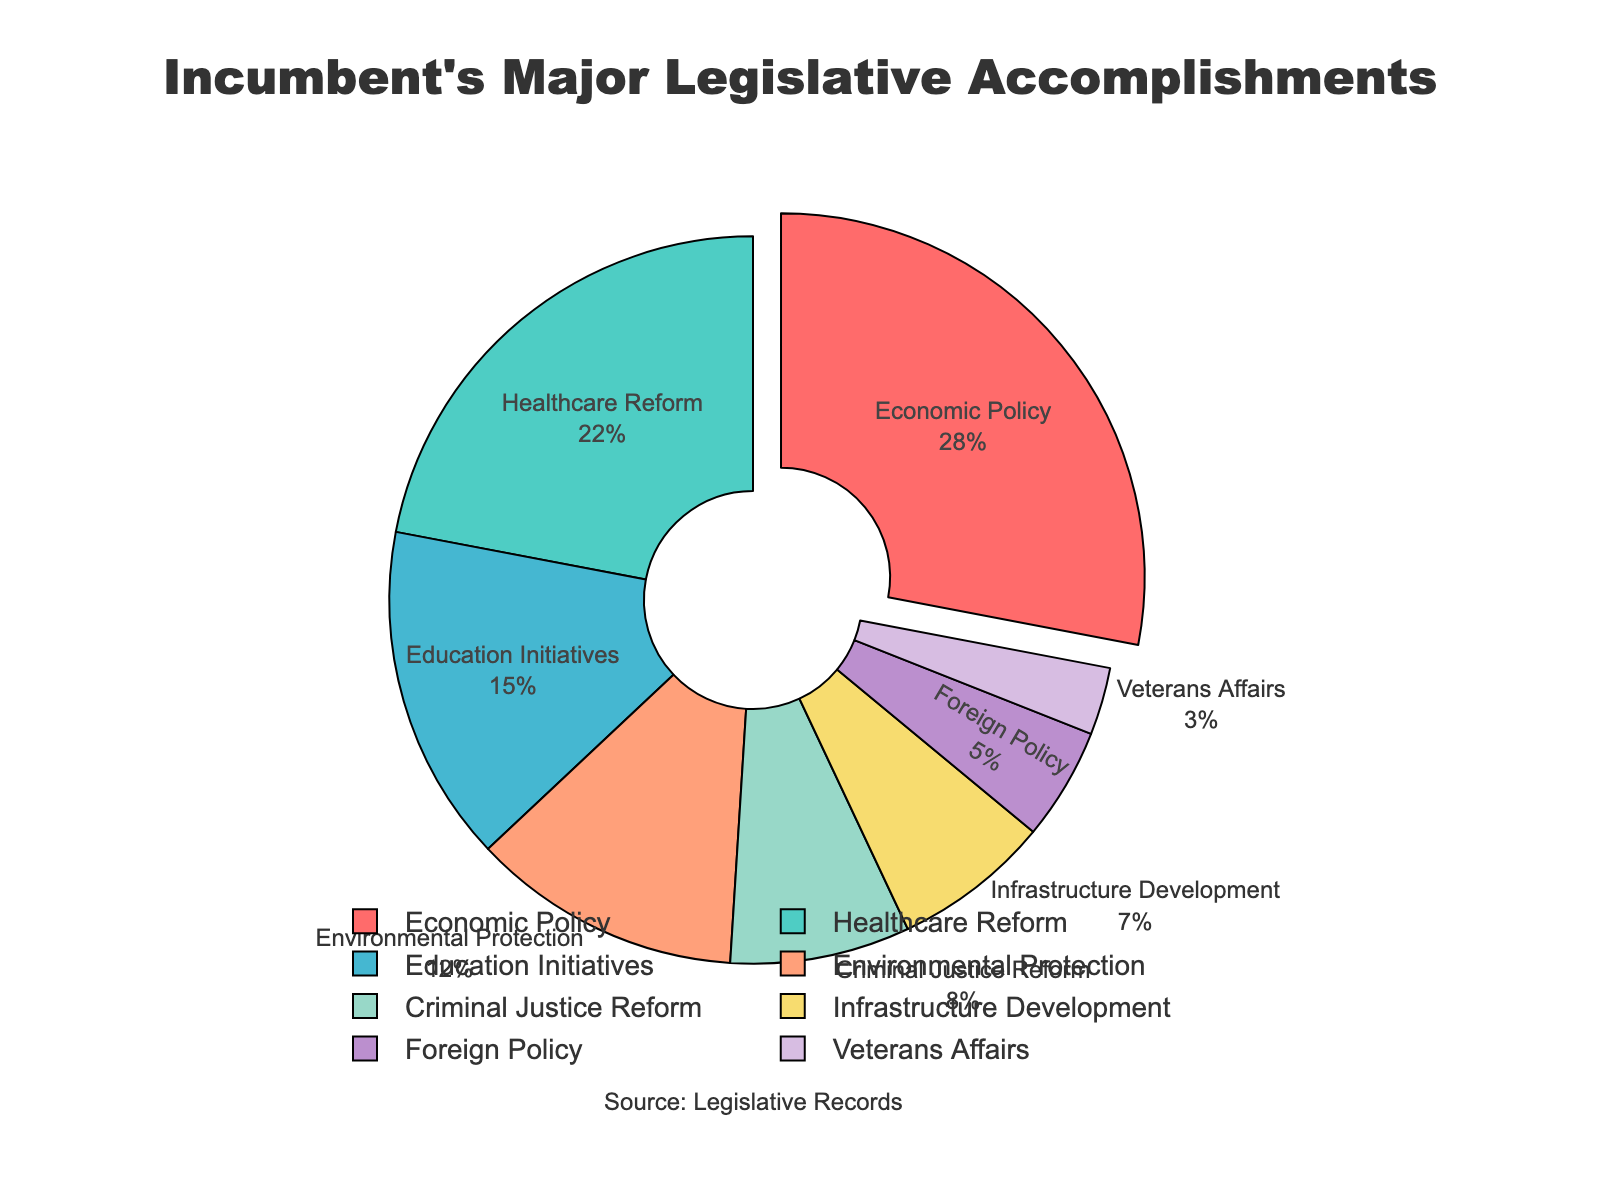What's the largest policy area by percentage share? The largest policy area is identified by finding the slice that has the highest percentage. In this case, the "Economic Policy" slice is pulled out, making it visually prominent and easy to identify as the largest.
Answer: Economic Policy What is the combined percentage of Education Initiatives, Environmental Protection, and Infrastructure Development? Sum the percentages of the three policy areas: Education Initiatives (15%) + Environmental Protection (12%) + Infrastructure Development (7%). The total is 15 + 12 + 7 = 34%.
Answer: 34 How does the percentage of Healthcare Reform compare to Foreign Policy? Compare the percentages of Healthcare Reform (22%) and Foreign Policy (5%). Healthcare Reform has a larger percentage.
Answer: Healthcare Reform is greater What fraction of the legislative accomplishments pertains to Criminal Justice Reform? Criminal Justice Reform represents 8% of the total. To convert this percentage to a fraction, note that 8% is 8 out of 100 or 8/100, which simplifies to 2/25.
Answer: 2/25 If you were to combine the percentages of Veterans Affairs and Healthcare Reform, what would be the result? Add the percentages of Veterans Affairs (3%) and Healthcare Reform (22%). The total is 3 + 22 = 25%.
Answer: 25 What policy area corresponds to the green-colored slice? Observing the colors in the chart and matching them to the labels, the green-colored slice represents Healthcare Reform.
Answer: Healthcare Reform Which three policy areas contribute to more than half of the legislative accomplishments combined? Identify the top three policy areas by their percentages and sum them. These are Economic Policy (28%), Healthcare Reform (22%), and Education Initiatives (15%). Their combined percentage is 28 + 22 + 15 = 65%, which is more than half of the total.
Answer: Economic Policy, Healthcare Reform, and Education Initiatives What is the least represented policy area? The least represented policy area is the one with the smallest percentage. In this case, Veterans Affairs at 3% is the smallest slice.
Answer: Veterans Affairs How much more does Economic Policy constitute compared to Infrastructure Development? Calculate the difference between the percentages of Economic Policy (28%) and Infrastructure Development (7%). The difference is 28 - 7 = 21%.
Answer: 21 